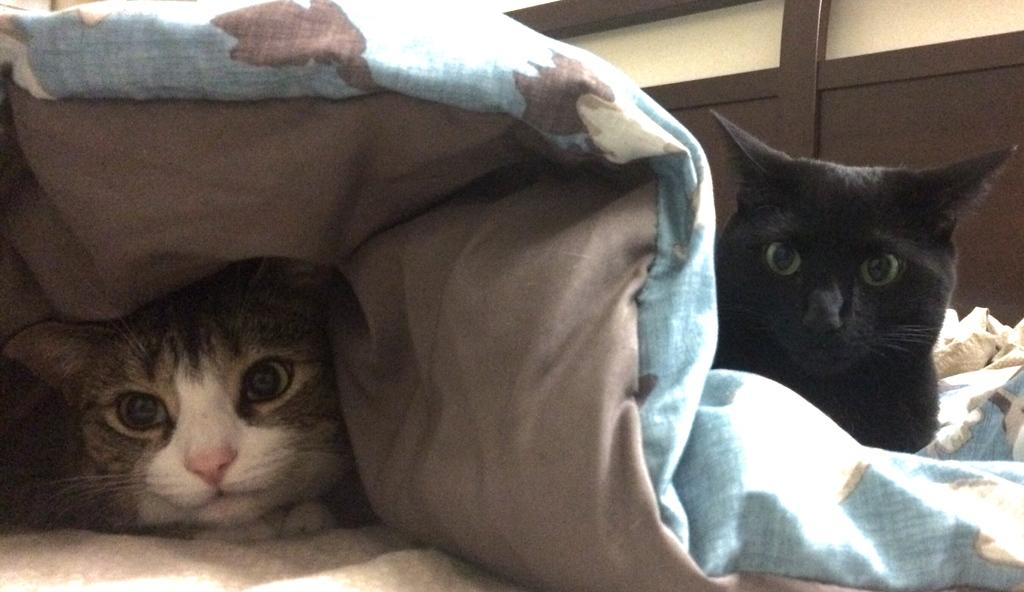How many cats are present in the image? There are two cats in the image. What colors are the cats? One cat is grey in color, and the other cat is black in color. What else can be seen in the image besides the cats? There is a blue cloth visible in the image. What type of jam is being spread on the plate by the giant in the image? There are no giants or plates present in the image; it only features two cats and a blue cloth. 